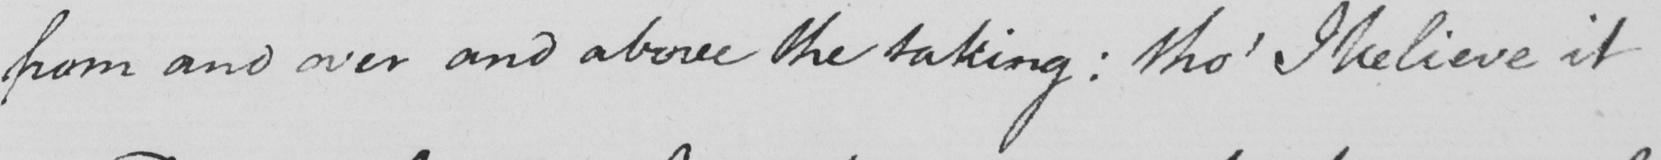Please provide the text content of this handwritten line. from and over and above the taking :  tho '  I believe it 